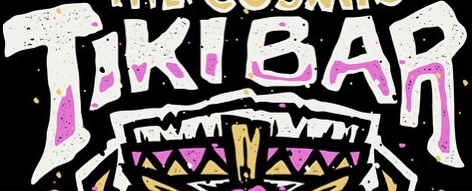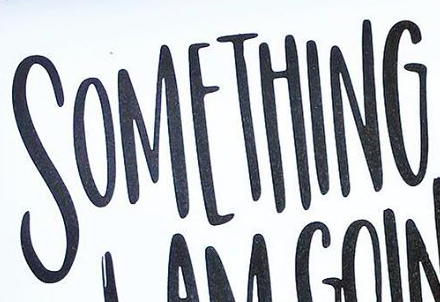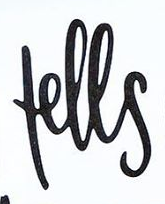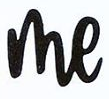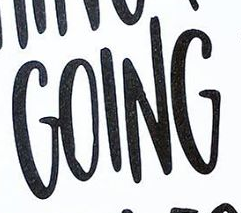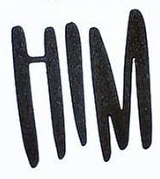Read the text content from these images in order, separated by a semicolon. TIKIBAR; SOMETHING; fells; me; GOING; HIM 